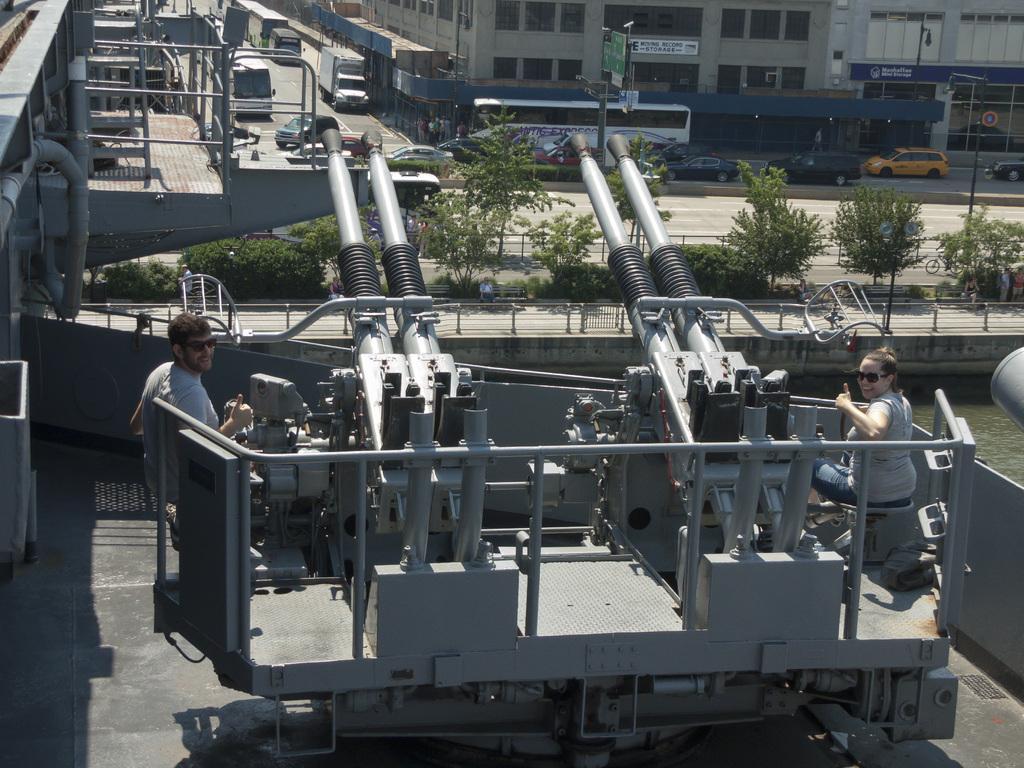In one or two sentences, can you explain what this image depicts? In this picture I can see two persons sitting and smiling, there are cannons, there are vehicles on the road, there are trees, and in the background there are buildings. 